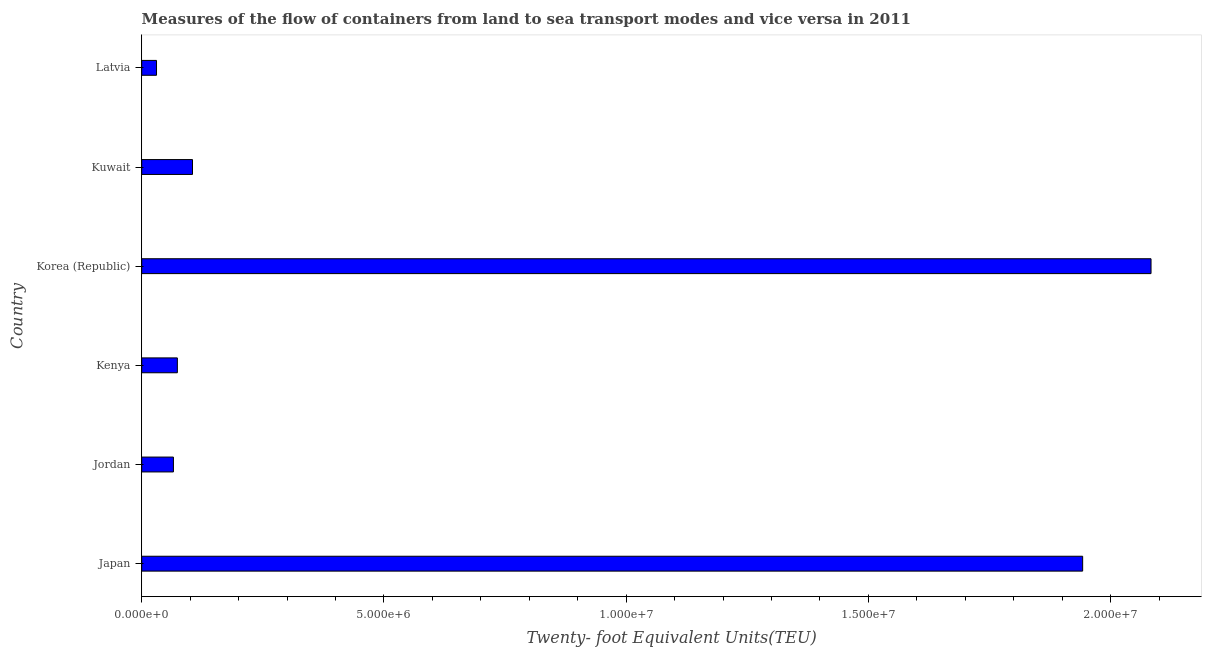Does the graph contain any zero values?
Your response must be concise. No. Does the graph contain grids?
Your answer should be compact. No. What is the title of the graph?
Offer a very short reply. Measures of the flow of containers from land to sea transport modes and vice versa in 2011. What is the label or title of the X-axis?
Provide a succinct answer. Twenty- foot Equivalent Units(TEU). What is the container port traffic in Jordan?
Provide a short and direct response. 6.54e+05. Across all countries, what is the maximum container port traffic?
Keep it short and to the point. 2.08e+07. Across all countries, what is the minimum container port traffic?
Ensure brevity in your answer.  3.05e+05. In which country was the container port traffic minimum?
Make the answer very short. Latvia. What is the sum of the container port traffic?
Offer a terse response. 4.30e+07. What is the difference between the container port traffic in Japan and Latvia?
Your response must be concise. 1.91e+07. What is the average container port traffic per country?
Offer a terse response. 7.17e+06. What is the median container port traffic?
Offer a terse response. 8.92e+05. In how many countries, is the container port traffic greater than 3000000 TEU?
Ensure brevity in your answer.  2. What is the ratio of the container port traffic in Jordan to that in Kenya?
Provide a short and direct response. 0.89. Is the container port traffic in Japan less than that in Latvia?
Give a very brief answer. No. What is the difference between the highest and the second highest container port traffic?
Offer a terse response. 1.41e+06. Is the sum of the container port traffic in Kuwait and Latvia greater than the maximum container port traffic across all countries?
Offer a very short reply. No. What is the difference between the highest and the lowest container port traffic?
Your response must be concise. 2.05e+07. How many bars are there?
Give a very brief answer. 6. Are all the bars in the graph horizontal?
Your answer should be compact. Yes. What is the difference between two consecutive major ticks on the X-axis?
Keep it short and to the point. 5.00e+06. Are the values on the major ticks of X-axis written in scientific E-notation?
Offer a very short reply. Yes. What is the Twenty- foot Equivalent Units(TEU) of Japan?
Give a very brief answer. 1.94e+07. What is the Twenty- foot Equivalent Units(TEU) of Jordan?
Your answer should be compact. 6.54e+05. What is the Twenty- foot Equivalent Units(TEU) in Kenya?
Provide a short and direct response. 7.36e+05. What is the Twenty- foot Equivalent Units(TEU) in Korea (Republic)?
Offer a terse response. 2.08e+07. What is the Twenty- foot Equivalent Units(TEU) of Kuwait?
Give a very brief answer. 1.05e+06. What is the Twenty- foot Equivalent Units(TEU) of Latvia?
Give a very brief answer. 3.05e+05. What is the difference between the Twenty- foot Equivalent Units(TEU) in Japan and Jordan?
Your answer should be compact. 1.88e+07. What is the difference between the Twenty- foot Equivalent Units(TEU) in Japan and Kenya?
Offer a terse response. 1.87e+07. What is the difference between the Twenty- foot Equivalent Units(TEU) in Japan and Korea (Republic)?
Offer a terse response. -1.41e+06. What is the difference between the Twenty- foot Equivalent Units(TEU) in Japan and Kuwait?
Give a very brief answer. 1.84e+07. What is the difference between the Twenty- foot Equivalent Units(TEU) in Japan and Latvia?
Offer a terse response. 1.91e+07. What is the difference between the Twenty- foot Equivalent Units(TEU) in Jordan and Kenya?
Keep it short and to the point. -8.14e+04. What is the difference between the Twenty- foot Equivalent Units(TEU) in Jordan and Korea (Republic)?
Provide a succinct answer. -2.02e+07. What is the difference between the Twenty- foot Equivalent Units(TEU) in Jordan and Kuwait?
Ensure brevity in your answer.  -3.94e+05. What is the difference between the Twenty- foot Equivalent Units(TEU) in Jordan and Latvia?
Provide a succinct answer. 3.49e+05. What is the difference between the Twenty- foot Equivalent Units(TEU) in Kenya and Korea (Republic)?
Ensure brevity in your answer.  -2.01e+07. What is the difference between the Twenty- foot Equivalent Units(TEU) in Kenya and Kuwait?
Make the answer very short. -3.12e+05. What is the difference between the Twenty- foot Equivalent Units(TEU) in Kenya and Latvia?
Your answer should be compact. 4.30e+05. What is the difference between the Twenty- foot Equivalent Units(TEU) in Korea (Republic) and Kuwait?
Offer a terse response. 1.98e+07. What is the difference between the Twenty- foot Equivalent Units(TEU) in Korea (Republic) and Latvia?
Provide a short and direct response. 2.05e+07. What is the difference between the Twenty- foot Equivalent Units(TEU) in Kuwait and Latvia?
Your response must be concise. 7.43e+05. What is the ratio of the Twenty- foot Equivalent Units(TEU) in Japan to that in Jordan?
Your answer should be very brief. 29.68. What is the ratio of the Twenty- foot Equivalent Units(TEU) in Japan to that in Kenya?
Your answer should be very brief. 26.4. What is the ratio of the Twenty- foot Equivalent Units(TEU) in Japan to that in Korea (Republic)?
Offer a very short reply. 0.93. What is the ratio of the Twenty- foot Equivalent Units(TEU) in Japan to that in Kuwait?
Keep it short and to the point. 18.53. What is the ratio of the Twenty- foot Equivalent Units(TEU) in Japan to that in Latvia?
Your response must be concise. 63.61. What is the ratio of the Twenty- foot Equivalent Units(TEU) in Jordan to that in Kenya?
Your response must be concise. 0.89. What is the ratio of the Twenty- foot Equivalent Units(TEU) in Jordan to that in Korea (Republic)?
Give a very brief answer. 0.03. What is the ratio of the Twenty- foot Equivalent Units(TEU) in Jordan to that in Kuwait?
Offer a terse response. 0.62. What is the ratio of the Twenty- foot Equivalent Units(TEU) in Jordan to that in Latvia?
Make the answer very short. 2.14. What is the ratio of the Twenty- foot Equivalent Units(TEU) in Kenya to that in Korea (Republic)?
Your answer should be compact. 0.04. What is the ratio of the Twenty- foot Equivalent Units(TEU) in Kenya to that in Kuwait?
Your answer should be compact. 0.7. What is the ratio of the Twenty- foot Equivalent Units(TEU) in Kenya to that in Latvia?
Your answer should be compact. 2.41. What is the ratio of the Twenty- foot Equivalent Units(TEU) in Korea (Republic) to that in Kuwait?
Provide a short and direct response. 19.88. What is the ratio of the Twenty- foot Equivalent Units(TEU) in Korea (Republic) to that in Latvia?
Offer a terse response. 68.23. What is the ratio of the Twenty- foot Equivalent Units(TEU) in Kuwait to that in Latvia?
Your answer should be compact. 3.43. 